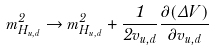<formula> <loc_0><loc_0><loc_500><loc_500>m _ { H _ { u , d } } ^ { 2 } \to m _ { H _ { u , d } } ^ { 2 } + \frac { 1 } { 2 v _ { u , d } } \frac { \partial ( \Delta V ) } { \partial v _ { u , d } }</formula> 